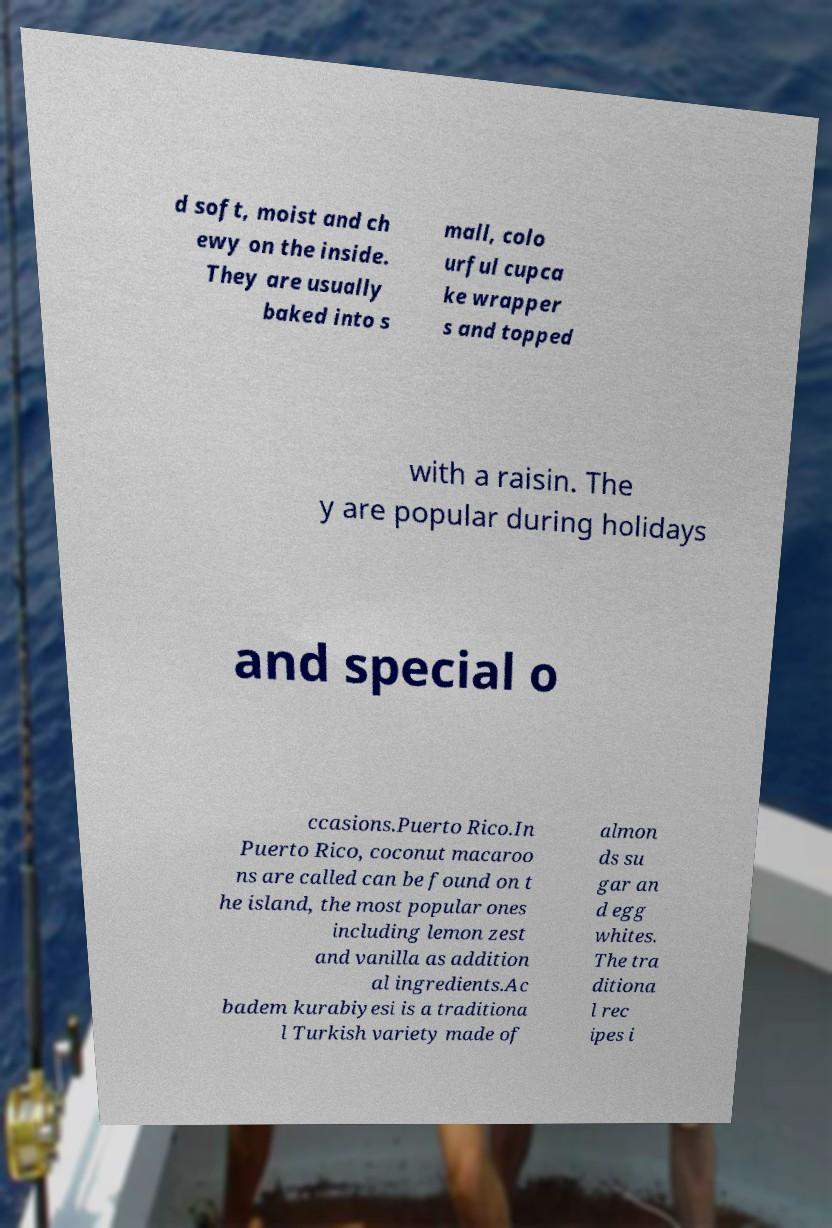Can you read and provide the text displayed in the image?This photo seems to have some interesting text. Can you extract and type it out for me? d soft, moist and ch ewy on the inside. They are usually baked into s mall, colo urful cupca ke wrapper s and topped with a raisin. The y are popular during holidays and special o ccasions.Puerto Rico.In Puerto Rico, coconut macaroo ns are called can be found on t he island, the most popular ones including lemon zest and vanilla as addition al ingredients.Ac badem kurabiyesi is a traditiona l Turkish variety made of almon ds su gar an d egg whites. The tra ditiona l rec ipes i 